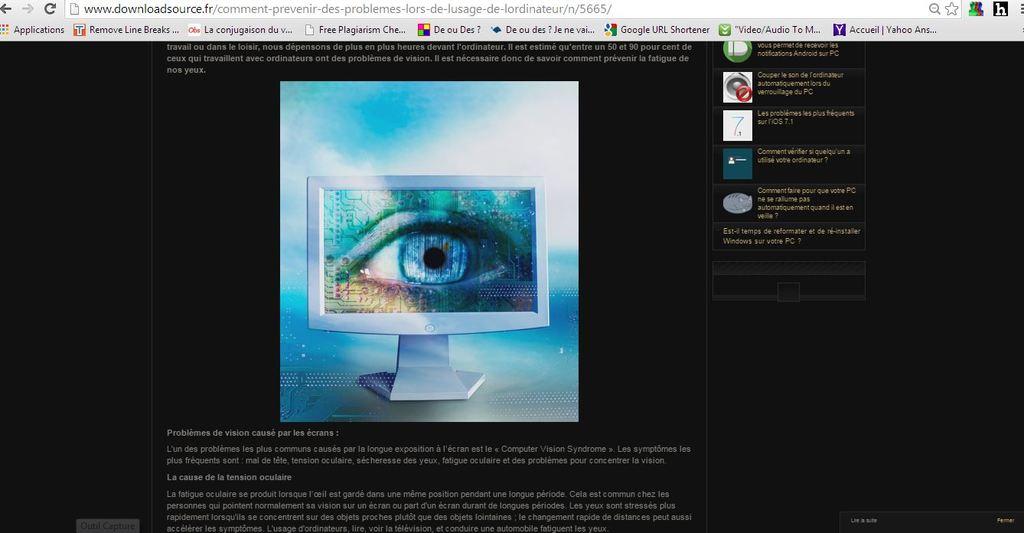What´s color is the eye on the picture?
Your response must be concise. Blue. 